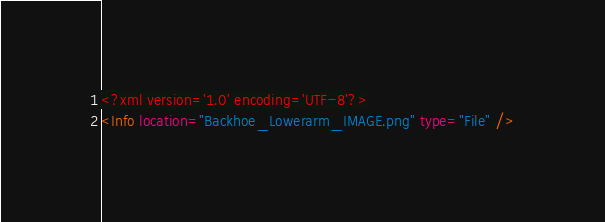Convert code to text. <code><loc_0><loc_0><loc_500><loc_500><_XML_><?xml version='1.0' encoding='UTF-8'?>
<Info location="Backhoe_Lowerarm_IMAGE.png" type="File" /></code> 